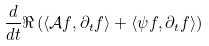Convert formula to latex. <formula><loc_0><loc_0><loc_500><loc_500>\frac { d } { d t } \Re \left ( \langle \mathcal { A } f , \partial _ { t } f \rangle + \langle \psi f , \partial _ { t } f \rangle \right )</formula> 